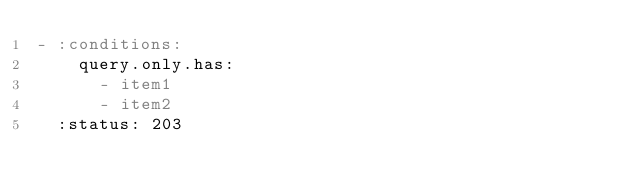<code> <loc_0><loc_0><loc_500><loc_500><_YAML_>- :conditions:
    query.only.has:
      - item1
      - item2
  :status: 203
</code> 